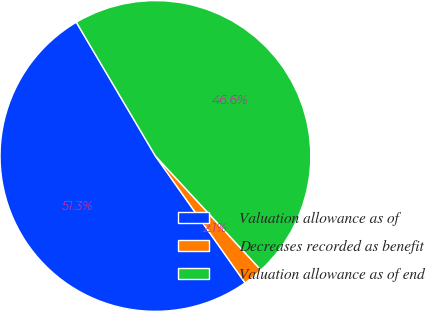Convert chart to OTSL. <chart><loc_0><loc_0><loc_500><loc_500><pie_chart><fcel>Valuation allowance as of<fcel>Decreases recorded as benefit<fcel>Valuation allowance as of end<nl><fcel>51.29%<fcel>2.09%<fcel>46.62%<nl></chart> 